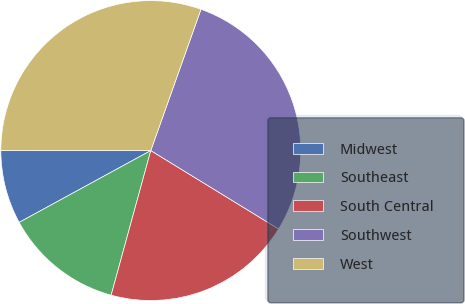<chart> <loc_0><loc_0><loc_500><loc_500><pie_chart><fcel>Midwest<fcel>Southeast<fcel>South Central<fcel>Southwest<fcel>West<nl><fcel>7.94%<fcel>12.79%<fcel>20.5%<fcel>28.32%<fcel>30.44%<nl></chart> 